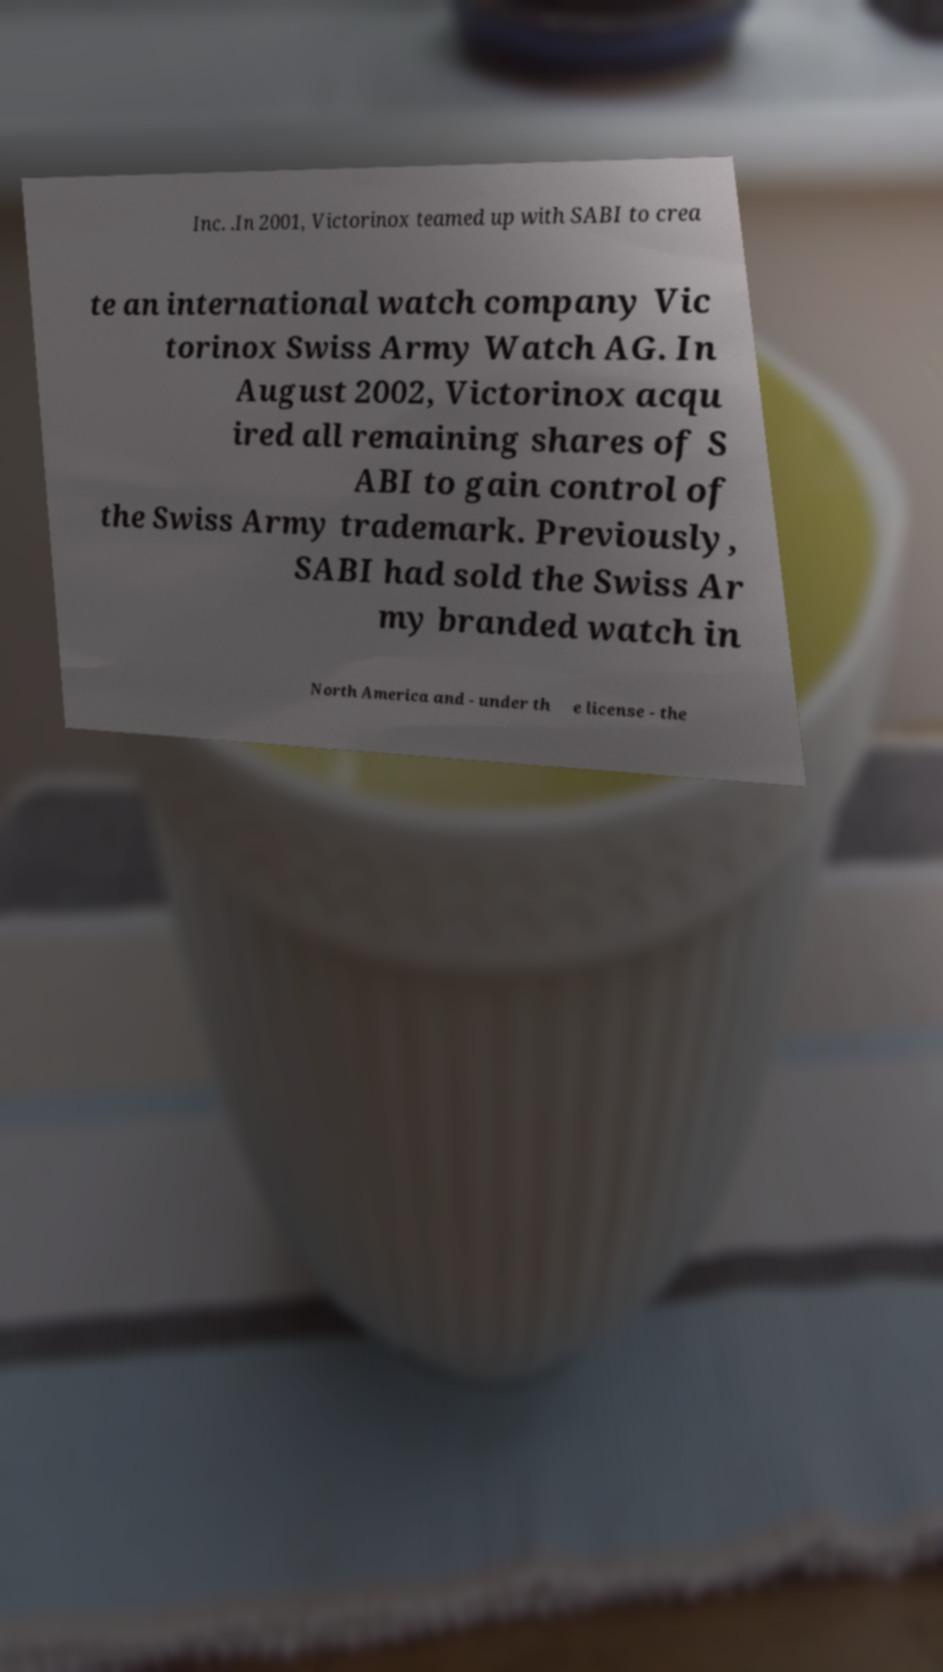Could you assist in decoding the text presented in this image and type it out clearly? Inc. .In 2001, Victorinox teamed up with SABI to crea te an international watch company Vic torinox Swiss Army Watch AG. In August 2002, Victorinox acqu ired all remaining shares of S ABI to gain control of the Swiss Army trademark. Previously, SABI had sold the Swiss Ar my branded watch in North America and - under th e license - the 